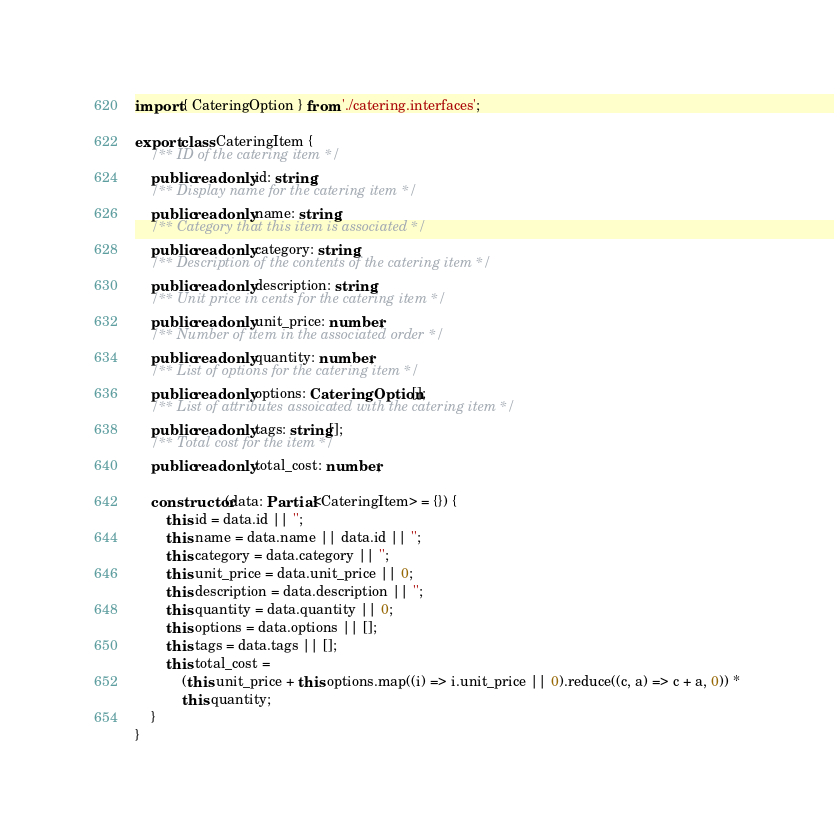Convert code to text. <code><loc_0><loc_0><loc_500><loc_500><_TypeScript_>import { CateringOption } from './catering.interfaces';

export class CateringItem {
    /** ID of the catering item */
    public readonly id: string;
    /** Display name for the catering item */
    public readonly name: string;
    /** Category that this item is associated */
    public readonly category: string;
    /** Description of the contents of the catering item */
    public readonly description: string;
    /** Unit price in cents for the catering item */
    public readonly unit_price: number;
    /** Number of item in the associated order */
    public readonly quantity: number;
    /** List of options for the catering item */
    public readonly options: CateringOption[];
    /** List of attributes assoicated with the catering item */
    public readonly tags: string[];
    /** Total cost for the item */
    public readonly total_cost: number;

    constructor(data: Partial<CateringItem> = {}) {
        this.id = data.id || '';
        this.name = data.name || data.id || '';
        this.category = data.category || '';
        this.unit_price = data.unit_price || 0;
        this.description = data.description || '';
        this.quantity = data.quantity || 0;
        this.options = data.options || [];
        this.tags = data.tags || [];
        this.total_cost =
            (this.unit_price + this.options.map((i) => i.unit_price || 0).reduce((c, a) => c + a, 0)) *
            this.quantity;
    }
}
</code> 